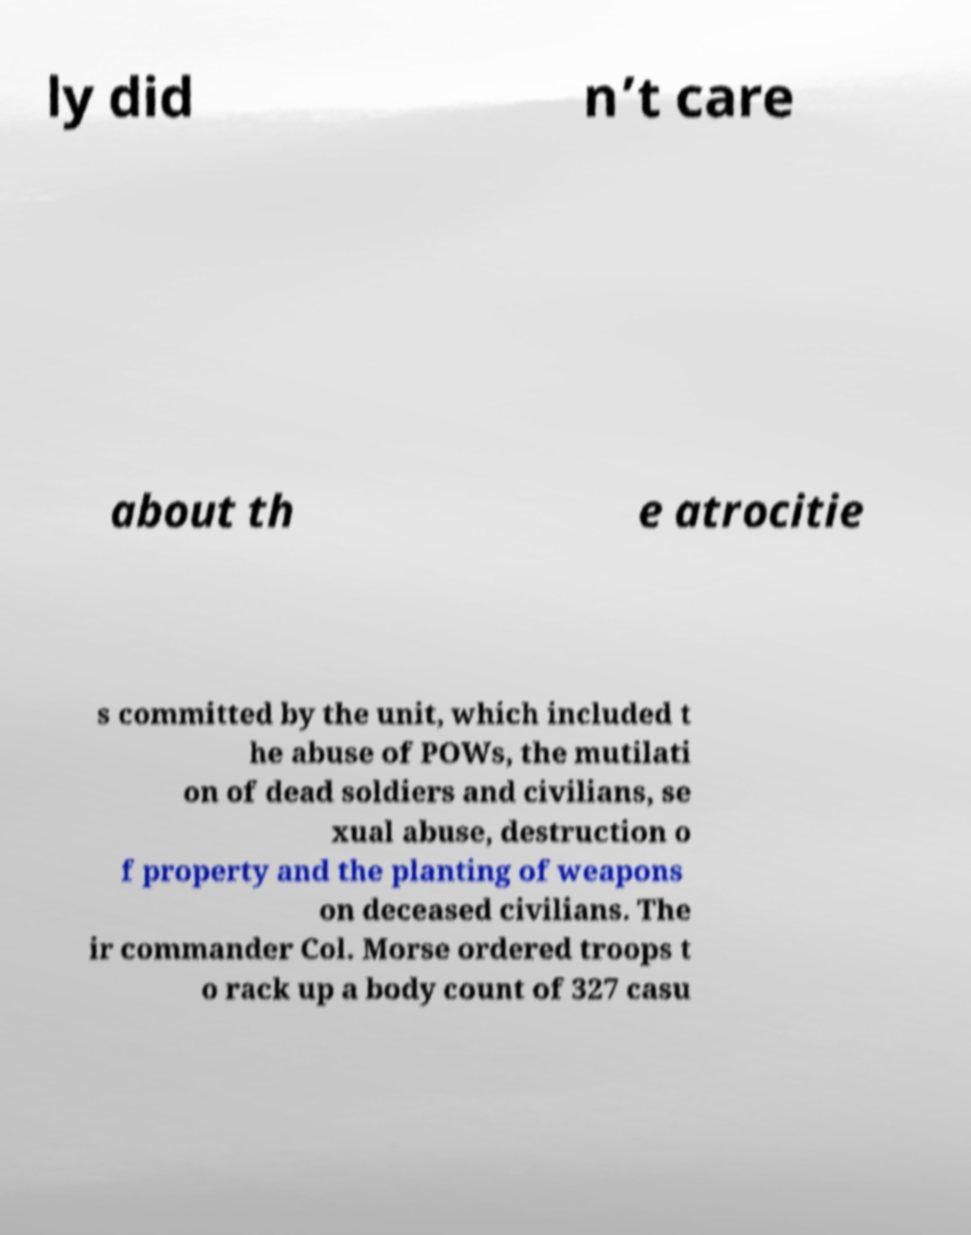What messages or text are displayed in this image? I need them in a readable, typed format. ly did n’t care about th e atrocitie s committed by the unit, which included t he abuse of POWs, the mutilati on of dead soldiers and civilians, se xual abuse, destruction o f property and the planting of weapons on deceased civilians. The ir commander Col. Morse ordered troops t o rack up a body count of 327 casu 